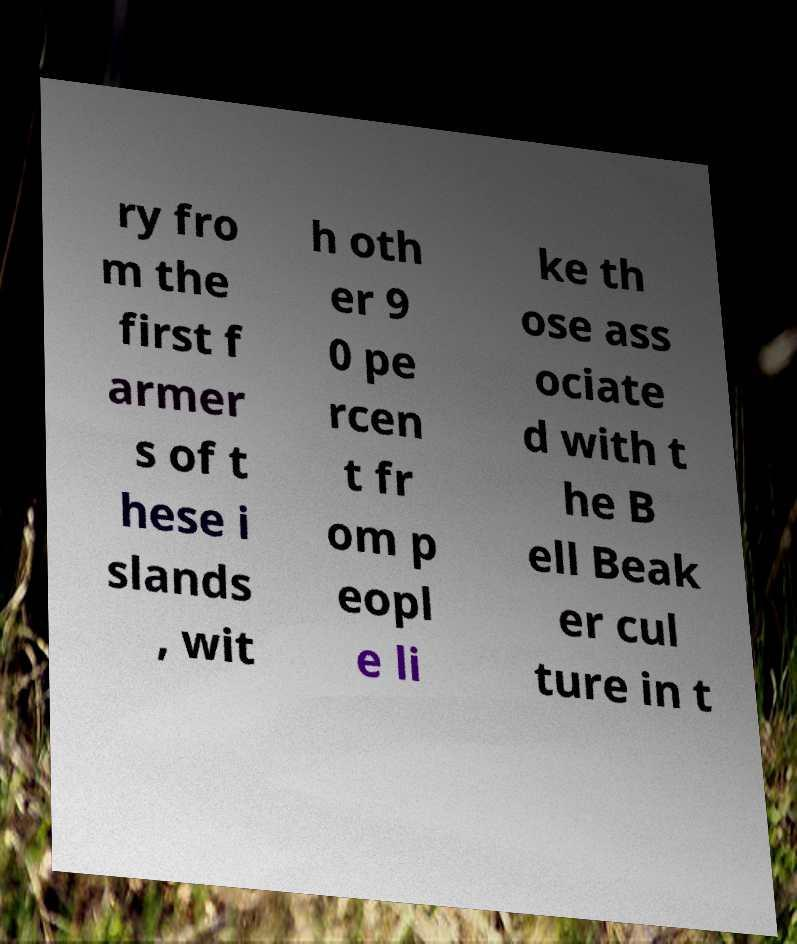Please identify and transcribe the text found in this image. ry fro m the first f armer s of t hese i slands , wit h oth er 9 0 pe rcen t fr om p eopl e li ke th ose ass ociate d with t he B ell Beak er cul ture in t 